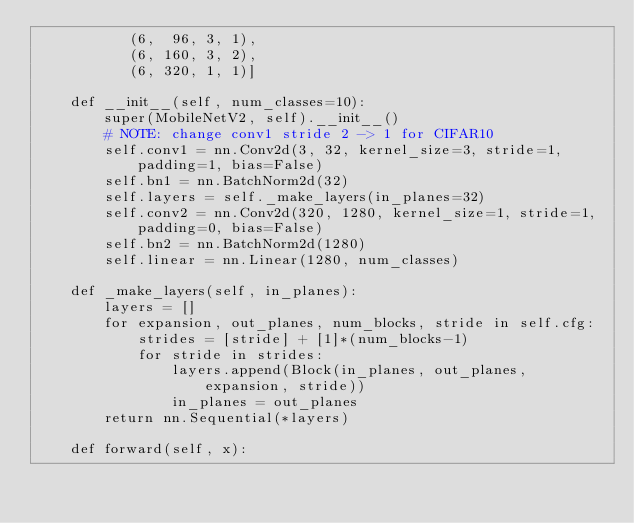<code> <loc_0><loc_0><loc_500><loc_500><_Python_>           (6,  96, 3, 1),
           (6, 160, 3, 2),
           (6, 320, 1, 1)]

    def __init__(self, num_classes=10):
        super(MobileNetV2, self).__init__()
        # NOTE: change conv1 stride 2 -> 1 for CIFAR10
        self.conv1 = nn.Conv2d(3, 32, kernel_size=3, stride=1, padding=1, bias=False)
        self.bn1 = nn.BatchNorm2d(32)
        self.layers = self._make_layers(in_planes=32)
        self.conv2 = nn.Conv2d(320, 1280, kernel_size=1, stride=1, padding=0, bias=False)
        self.bn2 = nn.BatchNorm2d(1280)
        self.linear = nn.Linear(1280, num_classes)

    def _make_layers(self, in_planes):
        layers = []
        for expansion, out_planes, num_blocks, stride in self.cfg:
            strides = [stride] + [1]*(num_blocks-1)
            for stride in strides:
                layers.append(Block(in_planes, out_planes, expansion, stride))
                in_planes = out_planes
        return nn.Sequential(*layers)

    def forward(self, x):</code> 